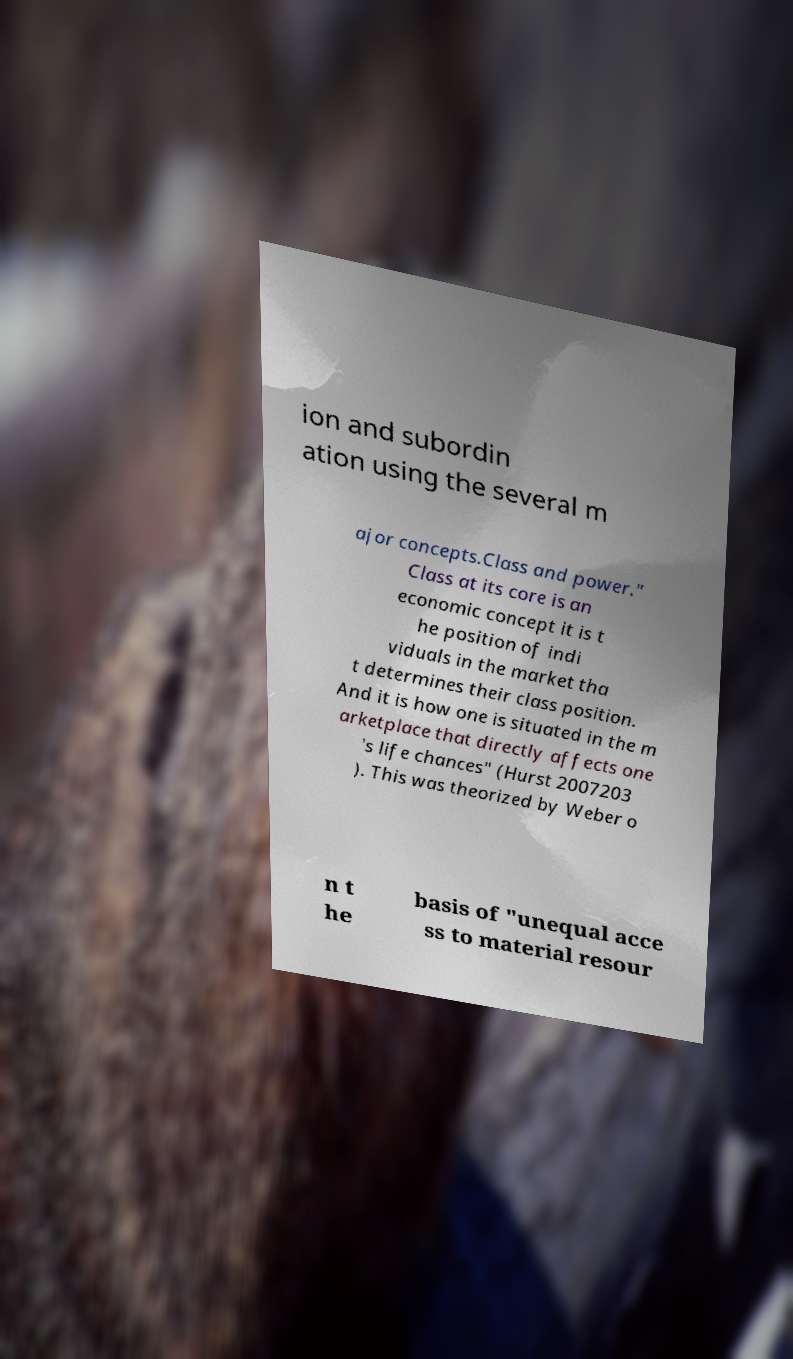For documentation purposes, I need the text within this image transcribed. Could you provide that? ion and subordin ation using the several m ajor concepts.Class and power." Class at its core is an economic concept it is t he position of indi viduals in the market tha t determines their class position. And it is how one is situated in the m arketplace that directly affects one 's life chances" (Hurst 2007203 ). This was theorized by Weber o n t he basis of "unequal acce ss to material resour 